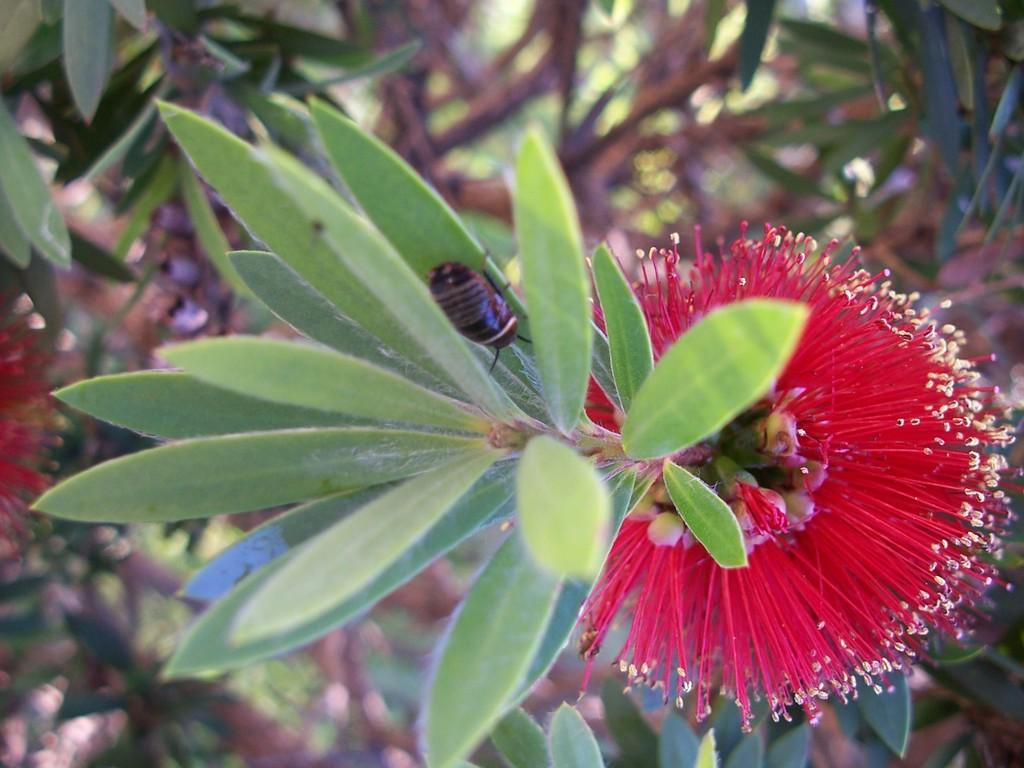What type of plant life is visible in the image? There are green leaves in the image. What color is the flower in the image? There is a red flower in the image. What type of creature can be seen in the image? There is a black insect in the image. What type of representative is present in the image? There is no representative present in the image; it features green leaves, a red flower, and a black insect. Can you tell me how much pain the flower is experiencing in the image? The image does not convey any information about the flower's experience of pain, as it is a still image of a plant. 